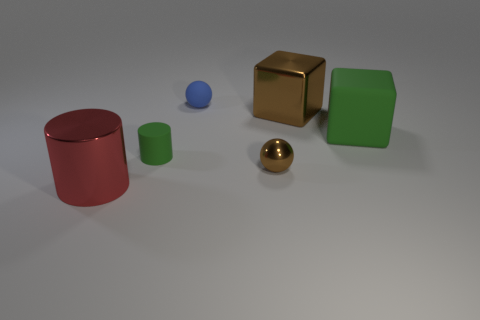There is a tiny matte object behind the block that is to the left of the big matte cube; what shape is it?
Keep it short and to the point. Sphere. Is there any other thing that is the same color as the small rubber sphere?
Provide a succinct answer. No. There is a rubber object behind the large metallic object that is to the right of the small blue rubber ball; is there a green rubber object to the right of it?
Offer a terse response. Yes. Does the tiny matte object in front of the small blue rubber sphere have the same color as the rubber object right of the tiny brown shiny thing?
Provide a succinct answer. Yes. What material is the green object that is the same size as the blue rubber object?
Provide a short and direct response. Rubber. What size is the blue sphere behind the ball in front of the big shiny thing that is right of the blue rubber ball?
Your response must be concise. Small. How many other things are there of the same material as the large cylinder?
Keep it short and to the point. 2. There is a brown metallic thing behind the big green rubber thing; what is its size?
Your response must be concise. Large. How many metallic objects are both behind the big metallic cylinder and on the left side of the blue rubber ball?
Ensure brevity in your answer.  0. The big cube in front of the big metallic object behind the red shiny object is made of what material?
Give a very brief answer. Rubber. 